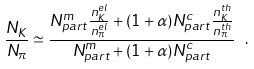<formula> <loc_0><loc_0><loc_500><loc_500>\frac { N _ { K } } { N _ { \pi } } \simeq \frac { N _ { p a r t } ^ { m } \frac { n _ { K } ^ { e l } } { n _ { \pi } ^ { e l } } + ( 1 + \alpha ) N _ { p a r t } ^ { c } \frac { n _ { K } ^ { t h } } { n _ { \pi } ^ { t h } } } { N _ { p a r t } ^ { m } + ( 1 + \alpha ) N _ { p a r t } ^ { c } } \ .</formula> 